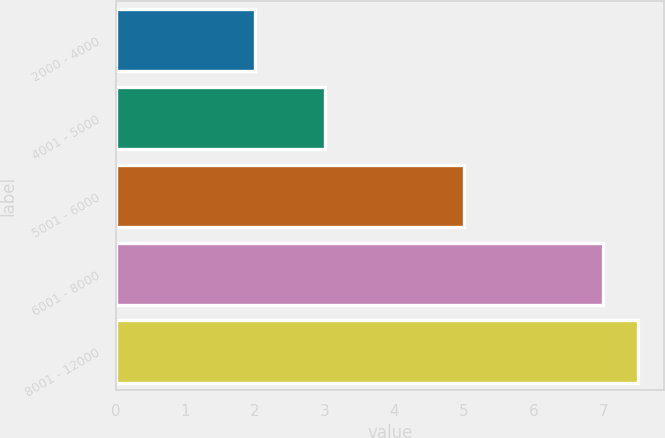<chart> <loc_0><loc_0><loc_500><loc_500><bar_chart><fcel>2000 - 4000<fcel>4001 - 5000<fcel>5001 - 6000<fcel>6001 - 8000<fcel>8001 - 12000<nl><fcel>2<fcel>3<fcel>5<fcel>7<fcel>7.5<nl></chart> 